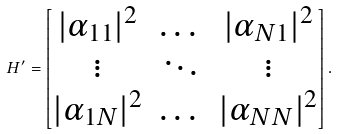<formula> <loc_0><loc_0><loc_500><loc_500>H ^ { \prime } = \begin{bmatrix} | \alpha _ { 1 1 } | ^ { 2 } & \dots & | \alpha _ { N 1 } | ^ { 2 } \\ \vdots & \ddots & \vdots \\ | \alpha _ { 1 N } | ^ { 2 } & \dots & | \alpha _ { N N } | ^ { 2 } \\ \end{bmatrix} .</formula> 